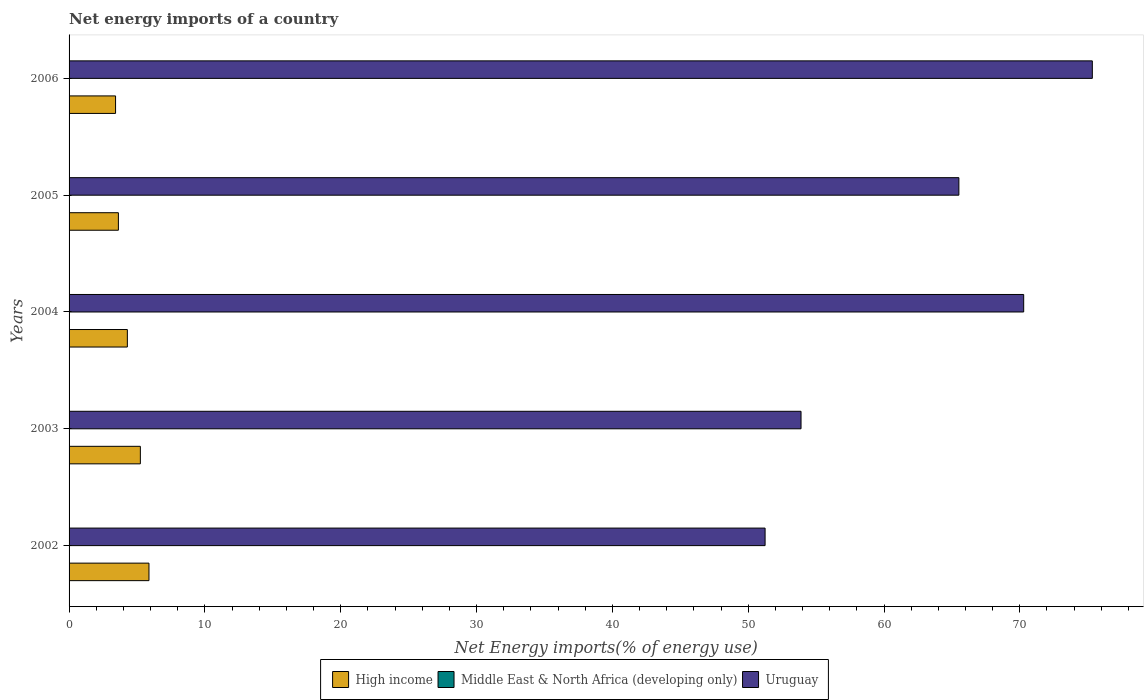How many different coloured bars are there?
Keep it short and to the point. 2. How many groups of bars are there?
Offer a terse response. 5. How many bars are there on the 3rd tick from the bottom?
Give a very brief answer. 2. Across all years, what is the maximum net energy imports in Uruguay?
Your response must be concise. 75.34. Across all years, what is the minimum net energy imports in Uruguay?
Keep it short and to the point. 51.25. In which year was the net energy imports in High income maximum?
Provide a short and direct response. 2002. What is the total net energy imports in High income in the graph?
Offer a terse response. 22.48. What is the difference between the net energy imports in High income in 2003 and that in 2004?
Offer a very short reply. 0.96. What is the difference between the net energy imports in Uruguay in 2004 and the net energy imports in Middle East & North Africa (developing only) in 2002?
Your answer should be compact. 70.29. What is the average net energy imports in Uruguay per year?
Ensure brevity in your answer.  63.25. In the year 2002, what is the difference between the net energy imports in High income and net energy imports in Uruguay?
Make the answer very short. -45.36. In how many years, is the net energy imports in Middle East & North Africa (developing only) greater than 58 %?
Ensure brevity in your answer.  0. What is the ratio of the net energy imports in High income in 2003 to that in 2004?
Your answer should be very brief. 1.22. Is the net energy imports in Uruguay in 2003 less than that in 2006?
Provide a short and direct response. Yes. Is the difference between the net energy imports in High income in 2002 and 2006 greater than the difference between the net energy imports in Uruguay in 2002 and 2006?
Provide a succinct answer. Yes. What is the difference between the highest and the second highest net energy imports in High income?
Give a very brief answer. 0.63. What is the difference between the highest and the lowest net energy imports in Uruguay?
Give a very brief answer. 24.09. Is the sum of the net energy imports in Uruguay in 2002 and 2004 greater than the maximum net energy imports in High income across all years?
Your answer should be very brief. Yes. How many bars are there?
Make the answer very short. 10. Are all the bars in the graph horizontal?
Give a very brief answer. Yes. How many years are there in the graph?
Offer a terse response. 5. Does the graph contain any zero values?
Your response must be concise. Yes. What is the title of the graph?
Your response must be concise. Net energy imports of a country. What is the label or title of the X-axis?
Offer a terse response. Net Energy imports(% of energy use). What is the Net Energy imports(% of energy use) in High income in 2002?
Provide a short and direct response. 5.88. What is the Net Energy imports(% of energy use) of Middle East & North Africa (developing only) in 2002?
Make the answer very short. 0. What is the Net Energy imports(% of energy use) of Uruguay in 2002?
Ensure brevity in your answer.  51.25. What is the Net Energy imports(% of energy use) of High income in 2003?
Your response must be concise. 5.25. What is the Net Energy imports(% of energy use) of Uruguay in 2003?
Make the answer very short. 53.89. What is the Net Energy imports(% of energy use) of High income in 2004?
Give a very brief answer. 4.29. What is the Net Energy imports(% of energy use) in Middle East & North Africa (developing only) in 2004?
Provide a short and direct response. 0. What is the Net Energy imports(% of energy use) in Uruguay in 2004?
Offer a terse response. 70.29. What is the Net Energy imports(% of energy use) of High income in 2005?
Make the answer very short. 3.63. What is the Net Energy imports(% of energy use) in Uruguay in 2005?
Make the answer very short. 65.51. What is the Net Energy imports(% of energy use) of High income in 2006?
Your answer should be compact. 3.42. What is the Net Energy imports(% of energy use) of Middle East & North Africa (developing only) in 2006?
Offer a terse response. 0. What is the Net Energy imports(% of energy use) of Uruguay in 2006?
Make the answer very short. 75.34. Across all years, what is the maximum Net Energy imports(% of energy use) in High income?
Make the answer very short. 5.88. Across all years, what is the maximum Net Energy imports(% of energy use) of Uruguay?
Your response must be concise. 75.34. Across all years, what is the minimum Net Energy imports(% of energy use) in High income?
Offer a very short reply. 3.42. Across all years, what is the minimum Net Energy imports(% of energy use) of Uruguay?
Your response must be concise. 51.25. What is the total Net Energy imports(% of energy use) in High income in the graph?
Provide a short and direct response. 22.48. What is the total Net Energy imports(% of energy use) in Middle East & North Africa (developing only) in the graph?
Make the answer very short. 0. What is the total Net Energy imports(% of energy use) in Uruguay in the graph?
Keep it short and to the point. 316.27. What is the difference between the Net Energy imports(% of energy use) of High income in 2002 and that in 2003?
Offer a terse response. 0.63. What is the difference between the Net Energy imports(% of energy use) of Uruguay in 2002 and that in 2003?
Ensure brevity in your answer.  -2.65. What is the difference between the Net Energy imports(% of energy use) in High income in 2002 and that in 2004?
Offer a terse response. 1.59. What is the difference between the Net Energy imports(% of energy use) of Uruguay in 2002 and that in 2004?
Your answer should be compact. -19.04. What is the difference between the Net Energy imports(% of energy use) in High income in 2002 and that in 2005?
Your response must be concise. 2.25. What is the difference between the Net Energy imports(% of energy use) in Uruguay in 2002 and that in 2005?
Make the answer very short. -14.27. What is the difference between the Net Energy imports(% of energy use) in High income in 2002 and that in 2006?
Offer a very short reply. 2.46. What is the difference between the Net Energy imports(% of energy use) of Uruguay in 2002 and that in 2006?
Offer a terse response. -24.09. What is the difference between the Net Energy imports(% of energy use) of High income in 2003 and that in 2004?
Make the answer very short. 0.96. What is the difference between the Net Energy imports(% of energy use) in Uruguay in 2003 and that in 2004?
Offer a very short reply. -16.39. What is the difference between the Net Energy imports(% of energy use) in High income in 2003 and that in 2005?
Your answer should be compact. 1.62. What is the difference between the Net Energy imports(% of energy use) in Uruguay in 2003 and that in 2005?
Your response must be concise. -11.62. What is the difference between the Net Energy imports(% of energy use) in High income in 2003 and that in 2006?
Your response must be concise. 1.83. What is the difference between the Net Energy imports(% of energy use) of Uruguay in 2003 and that in 2006?
Ensure brevity in your answer.  -21.45. What is the difference between the Net Energy imports(% of energy use) of High income in 2004 and that in 2005?
Provide a short and direct response. 0.66. What is the difference between the Net Energy imports(% of energy use) in Uruguay in 2004 and that in 2005?
Make the answer very short. 4.77. What is the difference between the Net Energy imports(% of energy use) of High income in 2004 and that in 2006?
Offer a terse response. 0.87. What is the difference between the Net Energy imports(% of energy use) of Uruguay in 2004 and that in 2006?
Provide a short and direct response. -5.05. What is the difference between the Net Energy imports(% of energy use) of High income in 2005 and that in 2006?
Your response must be concise. 0.21. What is the difference between the Net Energy imports(% of energy use) in Uruguay in 2005 and that in 2006?
Offer a terse response. -9.83. What is the difference between the Net Energy imports(% of energy use) of High income in 2002 and the Net Energy imports(% of energy use) of Uruguay in 2003?
Ensure brevity in your answer.  -48.01. What is the difference between the Net Energy imports(% of energy use) of High income in 2002 and the Net Energy imports(% of energy use) of Uruguay in 2004?
Your response must be concise. -64.4. What is the difference between the Net Energy imports(% of energy use) in High income in 2002 and the Net Energy imports(% of energy use) in Uruguay in 2005?
Give a very brief answer. -59.63. What is the difference between the Net Energy imports(% of energy use) of High income in 2002 and the Net Energy imports(% of energy use) of Uruguay in 2006?
Your answer should be compact. -69.46. What is the difference between the Net Energy imports(% of energy use) of High income in 2003 and the Net Energy imports(% of energy use) of Uruguay in 2004?
Provide a short and direct response. -65.04. What is the difference between the Net Energy imports(% of energy use) in High income in 2003 and the Net Energy imports(% of energy use) in Uruguay in 2005?
Your answer should be compact. -60.26. What is the difference between the Net Energy imports(% of energy use) of High income in 2003 and the Net Energy imports(% of energy use) of Uruguay in 2006?
Offer a terse response. -70.09. What is the difference between the Net Energy imports(% of energy use) in High income in 2004 and the Net Energy imports(% of energy use) in Uruguay in 2005?
Your response must be concise. -61.22. What is the difference between the Net Energy imports(% of energy use) in High income in 2004 and the Net Energy imports(% of energy use) in Uruguay in 2006?
Provide a succinct answer. -71.05. What is the difference between the Net Energy imports(% of energy use) in High income in 2005 and the Net Energy imports(% of energy use) in Uruguay in 2006?
Offer a very short reply. -71.71. What is the average Net Energy imports(% of energy use) in High income per year?
Ensure brevity in your answer.  4.5. What is the average Net Energy imports(% of energy use) of Middle East & North Africa (developing only) per year?
Offer a very short reply. 0. What is the average Net Energy imports(% of energy use) in Uruguay per year?
Provide a succinct answer. 63.25. In the year 2002, what is the difference between the Net Energy imports(% of energy use) of High income and Net Energy imports(% of energy use) of Uruguay?
Provide a short and direct response. -45.36. In the year 2003, what is the difference between the Net Energy imports(% of energy use) of High income and Net Energy imports(% of energy use) of Uruguay?
Offer a terse response. -48.64. In the year 2004, what is the difference between the Net Energy imports(% of energy use) of High income and Net Energy imports(% of energy use) of Uruguay?
Give a very brief answer. -65.99. In the year 2005, what is the difference between the Net Energy imports(% of energy use) of High income and Net Energy imports(% of energy use) of Uruguay?
Your answer should be very brief. -61.88. In the year 2006, what is the difference between the Net Energy imports(% of energy use) in High income and Net Energy imports(% of energy use) in Uruguay?
Your response must be concise. -71.92. What is the ratio of the Net Energy imports(% of energy use) of High income in 2002 to that in 2003?
Your answer should be very brief. 1.12. What is the ratio of the Net Energy imports(% of energy use) in Uruguay in 2002 to that in 2003?
Offer a terse response. 0.95. What is the ratio of the Net Energy imports(% of energy use) of High income in 2002 to that in 2004?
Offer a terse response. 1.37. What is the ratio of the Net Energy imports(% of energy use) in Uruguay in 2002 to that in 2004?
Give a very brief answer. 0.73. What is the ratio of the Net Energy imports(% of energy use) of High income in 2002 to that in 2005?
Your response must be concise. 1.62. What is the ratio of the Net Energy imports(% of energy use) in Uruguay in 2002 to that in 2005?
Your answer should be very brief. 0.78. What is the ratio of the Net Energy imports(% of energy use) of High income in 2002 to that in 2006?
Provide a short and direct response. 1.72. What is the ratio of the Net Energy imports(% of energy use) of Uruguay in 2002 to that in 2006?
Ensure brevity in your answer.  0.68. What is the ratio of the Net Energy imports(% of energy use) in High income in 2003 to that in 2004?
Keep it short and to the point. 1.22. What is the ratio of the Net Energy imports(% of energy use) in Uruguay in 2003 to that in 2004?
Make the answer very short. 0.77. What is the ratio of the Net Energy imports(% of energy use) of High income in 2003 to that in 2005?
Offer a terse response. 1.45. What is the ratio of the Net Energy imports(% of energy use) of Uruguay in 2003 to that in 2005?
Your response must be concise. 0.82. What is the ratio of the Net Energy imports(% of energy use) of High income in 2003 to that in 2006?
Keep it short and to the point. 1.53. What is the ratio of the Net Energy imports(% of energy use) of Uruguay in 2003 to that in 2006?
Make the answer very short. 0.72. What is the ratio of the Net Energy imports(% of energy use) in High income in 2004 to that in 2005?
Make the answer very short. 1.18. What is the ratio of the Net Energy imports(% of energy use) of Uruguay in 2004 to that in 2005?
Offer a terse response. 1.07. What is the ratio of the Net Energy imports(% of energy use) of High income in 2004 to that in 2006?
Your answer should be compact. 1.25. What is the ratio of the Net Energy imports(% of energy use) in Uruguay in 2004 to that in 2006?
Your response must be concise. 0.93. What is the ratio of the Net Energy imports(% of energy use) of High income in 2005 to that in 2006?
Your answer should be compact. 1.06. What is the ratio of the Net Energy imports(% of energy use) in Uruguay in 2005 to that in 2006?
Make the answer very short. 0.87. What is the difference between the highest and the second highest Net Energy imports(% of energy use) of High income?
Your response must be concise. 0.63. What is the difference between the highest and the second highest Net Energy imports(% of energy use) in Uruguay?
Offer a very short reply. 5.05. What is the difference between the highest and the lowest Net Energy imports(% of energy use) in High income?
Give a very brief answer. 2.46. What is the difference between the highest and the lowest Net Energy imports(% of energy use) in Uruguay?
Keep it short and to the point. 24.09. 